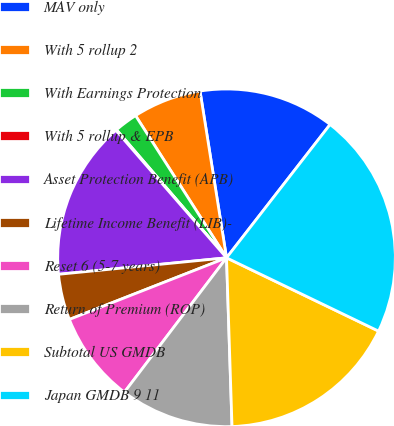Convert chart to OTSL. <chart><loc_0><loc_0><loc_500><loc_500><pie_chart><fcel>MAV only<fcel>With 5 rollup 2<fcel>With Earnings Protection<fcel>With 5 rollup & EPB<fcel>Asset Protection Benefit (APB)<fcel>Lifetime Income Benefit (LIB)-<fcel>Reset 6 (5-7 years)<fcel>Return of Premium (ROP)<fcel>Subtotal US GMDB<fcel>Japan GMDB 9 11<nl><fcel>13.02%<fcel>6.55%<fcel>2.24%<fcel>0.08%<fcel>15.18%<fcel>4.39%<fcel>8.71%<fcel>10.86%<fcel>17.33%<fcel>21.64%<nl></chart> 